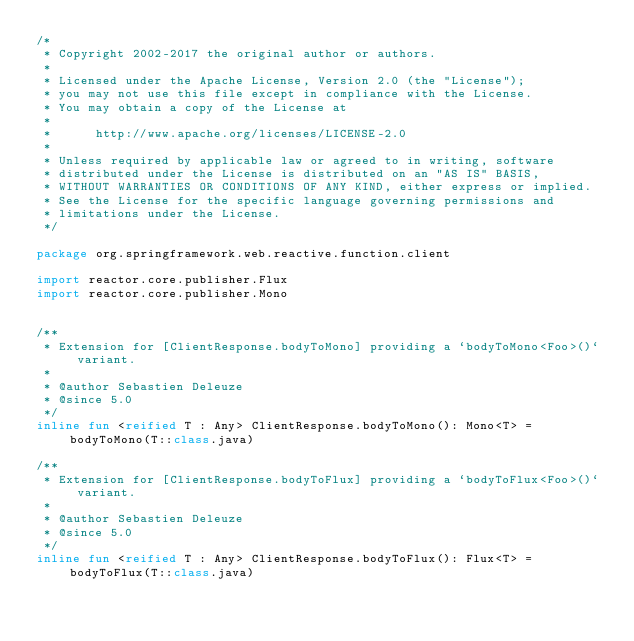<code> <loc_0><loc_0><loc_500><loc_500><_Kotlin_>/*
 * Copyright 2002-2017 the original author or authors.
 *
 * Licensed under the Apache License, Version 2.0 (the "License");
 * you may not use this file except in compliance with the License.
 * You may obtain a copy of the License at
 *
 *      http://www.apache.org/licenses/LICENSE-2.0
 *
 * Unless required by applicable law or agreed to in writing, software
 * distributed under the License is distributed on an "AS IS" BASIS,
 * WITHOUT WARRANTIES OR CONDITIONS OF ANY KIND, either express or implied.
 * See the License for the specific language governing permissions and
 * limitations under the License.
 */

package org.springframework.web.reactive.function.client

import reactor.core.publisher.Flux
import reactor.core.publisher.Mono


/**
 * Extension for [ClientResponse.bodyToMono] providing a `bodyToMono<Foo>()` variant.
 *
 * @author Sebastien Deleuze
 * @since 5.0
 */
inline fun <reified T : Any> ClientResponse.bodyToMono(): Mono<T> = bodyToMono(T::class.java)

/**
 * Extension for [ClientResponse.bodyToFlux] providing a `bodyToFlux<Foo>()` variant.
 *
 * @author Sebastien Deleuze
 * @since 5.0
 */
inline fun <reified T : Any> ClientResponse.bodyToFlux(): Flux<T> = bodyToFlux(T::class.java)
</code> 